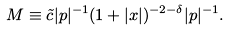Convert formula to latex. <formula><loc_0><loc_0><loc_500><loc_500>M \equiv \tilde { c } | p | ^ { - 1 } ( 1 + | x | ) ^ { - 2 - \delta } | p | ^ { - 1 } .</formula> 